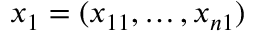<formula> <loc_0><loc_0><loc_500><loc_500>x _ { 1 } = ( x _ { 1 1 } , \dots , x _ { n 1 } )</formula> 